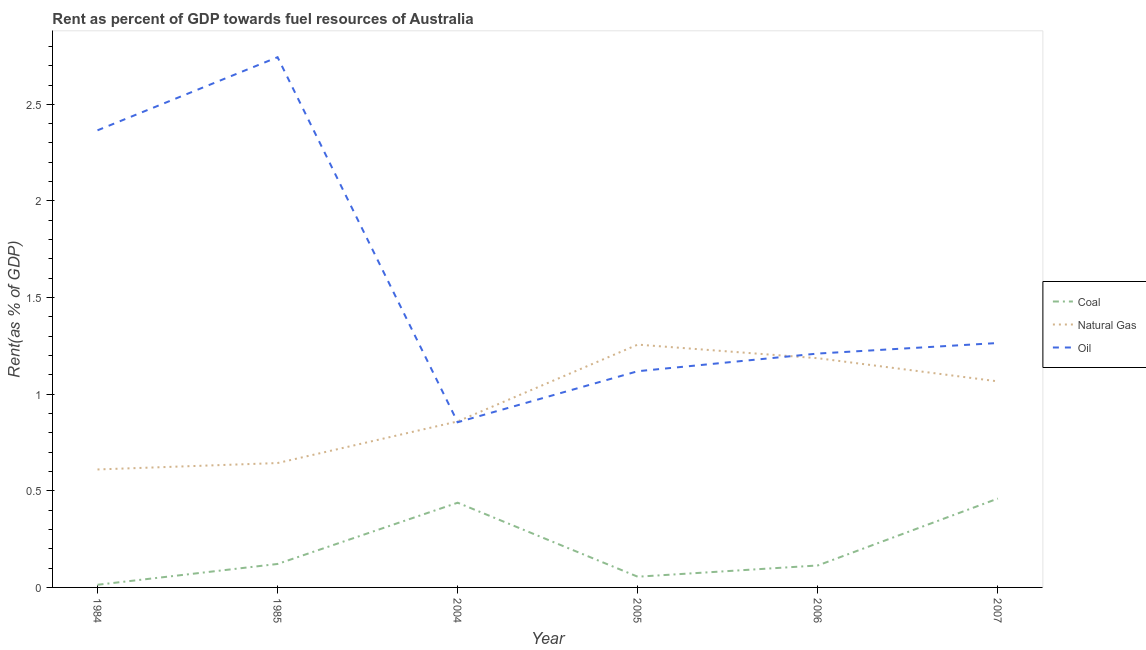Is the number of lines equal to the number of legend labels?
Provide a succinct answer. Yes. What is the rent towards coal in 2005?
Keep it short and to the point. 0.06. Across all years, what is the maximum rent towards natural gas?
Make the answer very short. 1.26. Across all years, what is the minimum rent towards natural gas?
Give a very brief answer. 0.61. In which year was the rent towards coal maximum?
Your answer should be compact. 2007. What is the total rent towards coal in the graph?
Make the answer very short. 1.2. What is the difference between the rent towards natural gas in 1984 and that in 2006?
Your response must be concise. -0.58. What is the difference between the rent towards oil in 1985 and the rent towards coal in 2005?
Make the answer very short. 2.69. What is the average rent towards oil per year?
Your answer should be very brief. 1.59. In the year 2007, what is the difference between the rent towards coal and rent towards natural gas?
Your response must be concise. -0.61. In how many years, is the rent towards natural gas greater than 0.8 %?
Give a very brief answer. 4. What is the ratio of the rent towards natural gas in 1984 to that in 2005?
Offer a terse response. 0.49. Is the rent towards coal in 1985 less than that in 2007?
Your response must be concise. Yes. What is the difference between the highest and the second highest rent towards coal?
Your answer should be very brief. 0.02. What is the difference between the highest and the lowest rent towards coal?
Provide a short and direct response. 0.45. Does the rent towards oil monotonically increase over the years?
Provide a short and direct response. No. Is the rent towards oil strictly greater than the rent towards coal over the years?
Give a very brief answer. Yes. What is the difference between two consecutive major ticks on the Y-axis?
Your answer should be compact. 0.5. Where does the legend appear in the graph?
Ensure brevity in your answer.  Center right. How many legend labels are there?
Your answer should be compact. 3. How are the legend labels stacked?
Your answer should be very brief. Vertical. What is the title of the graph?
Provide a succinct answer. Rent as percent of GDP towards fuel resources of Australia. What is the label or title of the X-axis?
Ensure brevity in your answer.  Year. What is the label or title of the Y-axis?
Make the answer very short. Rent(as % of GDP). What is the Rent(as % of GDP) of Coal in 1984?
Give a very brief answer. 0.01. What is the Rent(as % of GDP) in Natural Gas in 1984?
Your response must be concise. 0.61. What is the Rent(as % of GDP) in Oil in 1984?
Provide a succinct answer. 2.37. What is the Rent(as % of GDP) in Coal in 1985?
Your answer should be compact. 0.12. What is the Rent(as % of GDP) of Natural Gas in 1985?
Your response must be concise. 0.64. What is the Rent(as % of GDP) of Oil in 1985?
Provide a short and direct response. 2.74. What is the Rent(as % of GDP) in Coal in 2004?
Keep it short and to the point. 0.44. What is the Rent(as % of GDP) of Natural Gas in 2004?
Offer a very short reply. 0.86. What is the Rent(as % of GDP) in Oil in 2004?
Keep it short and to the point. 0.85. What is the Rent(as % of GDP) of Coal in 2005?
Ensure brevity in your answer.  0.06. What is the Rent(as % of GDP) in Natural Gas in 2005?
Your answer should be compact. 1.26. What is the Rent(as % of GDP) of Oil in 2005?
Give a very brief answer. 1.12. What is the Rent(as % of GDP) of Coal in 2006?
Keep it short and to the point. 0.11. What is the Rent(as % of GDP) in Natural Gas in 2006?
Provide a short and direct response. 1.19. What is the Rent(as % of GDP) of Oil in 2006?
Provide a short and direct response. 1.21. What is the Rent(as % of GDP) of Coal in 2007?
Provide a succinct answer. 0.46. What is the Rent(as % of GDP) in Natural Gas in 2007?
Ensure brevity in your answer.  1.07. What is the Rent(as % of GDP) in Oil in 2007?
Keep it short and to the point. 1.26. Across all years, what is the maximum Rent(as % of GDP) of Coal?
Offer a very short reply. 0.46. Across all years, what is the maximum Rent(as % of GDP) of Natural Gas?
Offer a terse response. 1.26. Across all years, what is the maximum Rent(as % of GDP) in Oil?
Offer a terse response. 2.74. Across all years, what is the minimum Rent(as % of GDP) of Coal?
Your answer should be very brief. 0.01. Across all years, what is the minimum Rent(as % of GDP) of Natural Gas?
Ensure brevity in your answer.  0.61. Across all years, what is the minimum Rent(as % of GDP) in Oil?
Offer a terse response. 0.85. What is the total Rent(as % of GDP) in Coal in the graph?
Offer a very short reply. 1.2. What is the total Rent(as % of GDP) of Natural Gas in the graph?
Offer a terse response. 5.62. What is the total Rent(as % of GDP) in Oil in the graph?
Your response must be concise. 9.56. What is the difference between the Rent(as % of GDP) of Coal in 1984 and that in 1985?
Offer a very short reply. -0.11. What is the difference between the Rent(as % of GDP) in Natural Gas in 1984 and that in 1985?
Offer a very short reply. -0.03. What is the difference between the Rent(as % of GDP) of Oil in 1984 and that in 1985?
Your response must be concise. -0.38. What is the difference between the Rent(as % of GDP) of Coal in 1984 and that in 2004?
Your answer should be very brief. -0.42. What is the difference between the Rent(as % of GDP) in Natural Gas in 1984 and that in 2004?
Provide a succinct answer. -0.25. What is the difference between the Rent(as % of GDP) of Oil in 1984 and that in 2004?
Offer a very short reply. 1.51. What is the difference between the Rent(as % of GDP) of Coal in 1984 and that in 2005?
Your response must be concise. -0.04. What is the difference between the Rent(as % of GDP) in Natural Gas in 1984 and that in 2005?
Provide a succinct answer. -0.65. What is the difference between the Rent(as % of GDP) of Oil in 1984 and that in 2005?
Provide a succinct answer. 1.25. What is the difference between the Rent(as % of GDP) of Coal in 1984 and that in 2006?
Ensure brevity in your answer.  -0.1. What is the difference between the Rent(as % of GDP) in Natural Gas in 1984 and that in 2006?
Ensure brevity in your answer.  -0.58. What is the difference between the Rent(as % of GDP) of Oil in 1984 and that in 2006?
Make the answer very short. 1.16. What is the difference between the Rent(as % of GDP) in Coal in 1984 and that in 2007?
Your response must be concise. -0.45. What is the difference between the Rent(as % of GDP) of Natural Gas in 1984 and that in 2007?
Provide a succinct answer. -0.46. What is the difference between the Rent(as % of GDP) in Oil in 1984 and that in 2007?
Provide a short and direct response. 1.1. What is the difference between the Rent(as % of GDP) in Coal in 1985 and that in 2004?
Offer a very short reply. -0.32. What is the difference between the Rent(as % of GDP) of Natural Gas in 1985 and that in 2004?
Give a very brief answer. -0.22. What is the difference between the Rent(as % of GDP) in Oil in 1985 and that in 2004?
Provide a succinct answer. 1.89. What is the difference between the Rent(as % of GDP) in Coal in 1985 and that in 2005?
Offer a terse response. 0.07. What is the difference between the Rent(as % of GDP) of Natural Gas in 1985 and that in 2005?
Provide a short and direct response. -0.61. What is the difference between the Rent(as % of GDP) in Oil in 1985 and that in 2005?
Offer a terse response. 1.62. What is the difference between the Rent(as % of GDP) in Coal in 1985 and that in 2006?
Offer a very short reply. 0.01. What is the difference between the Rent(as % of GDP) of Natural Gas in 1985 and that in 2006?
Make the answer very short. -0.54. What is the difference between the Rent(as % of GDP) of Oil in 1985 and that in 2006?
Ensure brevity in your answer.  1.53. What is the difference between the Rent(as % of GDP) of Coal in 1985 and that in 2007?
Give a very brief answer. -0.34. What is the difference between the Rent(as % of GDP) in Natural Gas in 1985 and that in 2007?
Your response must be concise. -0.42. What is the difference between the Rent(as % of GDP) in Oil in 1985 and that in 2007?
Offer a terse response. 1.48. What is the difference between the Rent(as % of GDP) in Coal in 2004 and that in 2005?
Offer a very short reply. 0.38. What is the difference between the Rent(as % of GDP) of Natural Gas in 2004 and that in 2005?
Offer a very short reply. -0.4. What is the difference between the Rent(as % of GDP) of Oil in 2004 and that in 2005?
Make the answer very short. -0.26. What is the difference between the Rent(as % of GDP) in Coal in 2004 and that in 2006?
Ensure brevity in your answer.  0.32. What is the difference between the Rent(as % of GDP) of Natural Gas in 2004 and that in 2006?
Ensure brevity in your answer.  -0.33. What is the difference between the Rent(as % of GDP) in Oil in 2004 and that in 2006?
Provide a succinct answer. -0.36. What is the difference between the Rent(as % of GDP) of Coal in 2004 and that in 2007?
Provide a succinct answer. -0.02. What is the difference between the Rent(as % of GDP) of Natural Gas in 2004 and that in 2007?
Make the answer very short. -0.21. What is the difference between the Rent(as % of GDP) of Oil in 2004 and that in 2007?
Your answer should be very brief. -0.41. What is the difference between the Rent(as % of GDP) of Coal in 2005 and that in 2006?
Give a very brief answer. -0.06. What is the difference between the Rent(as % of GDP) in Natural Gas in 2005 and that in 2006?
Ensure brevity in your answer.  0.07. What is the difference between the Rent(as % of GDP) of Oil in 2005 and that in 2006?
Your response must be concise. -0.09. What is the difference between the Rent(as % of GDP) in Coal in 2005 and that in 2007?
Your response must be concise. -0.4. What is the difference between the Rent(as % of GDP) in Natural Gas in 2005 and that in 2007?
Offer a terse response. 0.19. What is the difference between the Rent(as % of GDP) of Oil in 2005 and that in 2007?
Keep it short and to the point. -0.15. What is the difference between the Rent(as % of GDP) of Coal in 2006 and that in 2007?
Keep it short and to the point. -0.35. What is the difference between the Rent(as % of GDP) in Natural Gas in 2006 and that in 2007?
Provide a succinct answer. 0.12. What is the difference between the Rent(as % of GDP) of Oil in 2006 and that in 2007?
Your response must be concise. -0.05. What is the difference between the Rent(as % of GDP) of Coal in 1984 and the Rent(as % of GDP) of Natural Gas in 1985?
Provide a succinct answer. -0.63. What is the difference between the Rent(as % of GDP) of Coal in 1984 and the Rent(as % of GDP) of Oil in 1985?
Ensure brevity in your answer.  -2.73. What is the difference between the Rent(as % of GDP) in Natural Gas in 1984 and the Rent(as % of GDP) in Oil in 1985?
Provide a succinct answer. -2.13. What is the difference between the Rent(as % of GDP) of Coal in 1984 and the Rent(as % of GDP) of Natural Gas in 2004?
Make the answer very short. -0.85. What is the difference between the Rent(as % of GDP) in Coal in 1984 and the Rent(as % of GDP) in Oil in 2004?
Offer a very short reply. -0.84. What is the difference between the Rent(as % of GDP) in Natural Gas in 1984 and the Rent(as % of GDP) in Oil in 2004?
Give a very brief answer. -0.24. What is the difference between the Rent(as % of GDP) of Coal in 1984 and the Rent(as % of GDP) of Natural Gas in 2005?
Offer a terse response. -1.24. What is the difference between the Rent(as % of GDP) of Coal in 1984 and the Rent(as % of GDP) of Oil in 2005?
Keep it short and to the point. -1.11. What is the difference between the Rent(as % of GDP) of Natural Gas in 1984 and the Rent(as % of GDP) of Oil in 2005?
Give a very brief answer. -0.51. What is the difference between the Rent(as % of GDP) in Coal in 1984 and the Rent(as % of GDP) in Natural Gas in 2006?
Give a very brief answer. -1.17. What is the difference between the Rent(as % of GDP) in Coal in 1984 and the Rent(as % of GDP) in Oil in 2006?
Provide a short and direct response. -1.2. What is the difference between the Rent(as % of GDP) in Natural Gas in 1984 and the Rent(as % of GDP) in Oil in 2006?
Provide a short and direct response. -0.6. What is the difference between the Rent(as % of GDP) in Coal in 1984 and the Rent(as % of GDP) in Natural Gas in 2007?
Your answer should be compact. -1.05. What is the difference between the Rent(as % of GDP) of Coal in 1984 and the Rent(as % of GDP) of Oil in 2007?
Your response must be concise. -1.25. What is the difference between the Rent(as % of GDP) in Natural Gas in 1984 and the Rent(as % of GDP) in Oil in 2007?
Make the answer very short. -0.65. What is the difference between the Rent(as % of GDP) of Coal in 1985 and the Rent(as % of GDP) of Natural Gas in 2004?
Ensure brevity in your answer.  -0.74. What is the difference between the Rent(as % of GDP) in Coal in 1985 and the Rent(as % of GDP) in Oil in 2004?
Provide a short and direct response. -0.73. What is the difference between the Rent(as % of GDP) in Natural Gas in 1985 and the Rent(as % of GDP) in Oil in 2004?
Provide a short and direct response. -0.21. What is the difference between the Rent(as % of GDP) in Coal in 1985 and the Rent(as % of GDP) in Natural Gas in 2005?
Provide a succinct answer. -1.14. What is the difference between the Rent(as % of GDP) in Coal in 1985 and the Rent(as % of GDP) in Oil in 2005?
Your answer should be compact. -1. What is the difference between the Rent(as % of GDP) of Natural Gas in 1985 and the Rent(as % of GDP) of Oil in 2005?
Your answer should be compact. -0.48. What is the difference between the Rent(as % of GDP) of Coal in 1985 and the Rent(as % of GDP) of Natural Gas in 2006?
Give a very brief answer. -1.06. What is the difference between the Rent(as % of GDP) of Coal in 1985 and the Rent(as % of GDP) of Oil in 2006?
Keep it short and to the point. -1.09. What is the difference between the Rent(as % of GDP) of Natural Gas in 1985 and the Rent(as % of GDP) of Oil in 2006?
Your answer should be very brief. -0.57. What is the difference between the Rent(as % of GDP) of Coal in 1985 and the Rent(as % of GDP) of Natural Gas in 2007?
Provide a short and direct response. -0.94. What is the difference between the Rent(as % of GDP) in Coal in 1985 and the Rent(as % of GDP) in Oil in 2007?
Make the answer very short. -1.14. What is the difference between the Rent(as % of GDP) of Natural Gas in 1985 and the Rent(as % of GDP) of Oil in 2007?
Provide a short and direct response. -0.62. What is the difference between the Rent(as % of GDP) in Coal in 2004 and the Rent(as % of GDP) in Natural Gas in 2005?
Offer a terse response. -0.82. What is the difference between the Rent(as % of GDP) of Coal in 2004 and the Rent(as % of GDP) of Oil in 2005?
Provide a short and direct response. -0.68. What is the difference between the Rent(as % of GDP) of Natural Gas in 2004 and the Rent(as % of GDP) of Oil in 2005?
Your answer should be very brief. -0.26. What is the difference between the Rent(as % of GDP) in Coal in 2004 and the Rent(as % of GDP) in Natural Gas in 2006?
Give a very brief answer. -0.75. What is the difference between the Rent(as % of GDP) of Coal in 2004 and the Rent(as % of GDP) of Oil in 2006?
Ensure brevity in your answer.  -0.77. What is the difference between the Rent(as % of GDP) of Natural Gas in 2004 and the Rent(as % of GDP) of Oil in 2006?
Offer a terse response. -0.35. What is the difference between the Rent(as % of GDP) of Coal in 2004 and the Rent(as % of GDP) of Natural Gas in 2007?
Make the answer very short. -0.63. What is the difference between the Rent(as % of GDP) of Coal in 2004 and the Rent(as % of GDP) of Oil in 2007?
Provide a succinct answer. -0.83. What is the difference between the Rent(as % of GDP) in Natural Gas in 2004 and the Rent(as % of GDP) in Oil in 2007?
Ensure brevity in your answer.  -0.41. What is the difference between the Rent(as % of GDP) of Coal in 2005 and the Rent(as % of GDP) of Natural Gas in 2006?
Give a very brief answer. -1.13. What is the difference between the Rent(as % of GDP) in Coal in 2005 and the Rent(as % of GDP) in Oil in 2006?
Provide a succinct answer. -1.15. What is the difference between the Rent(as % of GDP) of Natural Gas in 2005 and the Rent(as % of GDP) of Oil in 2006?
Make the answer very short. 0.05. What is the difference between the Rent(as % of GDP) of Coal in 2005 and the Rent(as % of GDP) of Natural Gas in 2007?
Your answer should be very brief. -1.01. What is the difference between the Rent(as % of GDP) of Coal in 2005 and the Rent(as % of GDP) of Oil in 2007?
Your answer should be very brief. -1.21. What is the difference between the Rent(as % of GDP) of Natural Gas in 2005 and the Rent(as % of GDP) of Oil in 2007?
Provide a succinct answer. -0.01. What is the difference between the Rent(as % of GDP) in Coal in 2006 and the Rent(as % of GDP) in Natural Gas in 2007?
Your answer should be compact. -0.95. What is the difference between the Rent(as % of GDP) in Coal in 2006 and the Rent(as % of GDP) in Oil in 2007?
Keep it short and to the point. -1.15. What is the difference between the Rent(as % of GDP) of Natural Gas in 2006 and the Rent(as % of GDP) of Oil in 2007?
Provide a short and direct response. -0.08. What is the average Rent(as % of GDP) in Coal per year?
Your response must be concise. 0.2. What is the average Rent(as % of GDP) of Natural Gas per year?
Provide a succinct answer. 0.94. What is the average Rent(as % of GDP) in Oil per year?
Your response must be concise. 1.59. In the year 1984, what is the difference between the Rent(as % of GDP) in Coal and Rent(as % of GDP) in Natural Gas?
Your answer should be compact. -0.6. In the year 1984, what is the difference between the Rent(as % of GDP) in Coal and Rent(as % of GDP) in Oil?
Your answer should be very brief. -2.35. In the year 1984, what is the difference between the Rent(as % of GDP) of Natural Gas and Rent(as % of GDP) of Oil?
Provide a short and direct response. -1.75. In the year 1985, what is the difference between the Rent(as % of GDP) in Coal and Rent(as % of GDP) in Natural Gas?
Your answer should be very brief. -0.52. In the year 1985, what is the difference between the Rent(as % of GDP) in Coal and Rent(as % of GDP) in Oil?
Your answer should be very brief. -2.62. In the year 1985, what is the difference between the Rent(as % of GDP) of Natural Gas and Rent(as % of GDP) of Oil?
Give a very brief answer. -2.1. In the year 2004, what is the difference between the Rent(as % of GDP) in Coal and Rent(as % of GDP) in Natural Gas?
Your response must be concise. -0.42. In the year 2004, what is the difference between the Rent(as % of GDP) in Coal and Rent(as % of GDP) in Oil?
Your response must be concise. -0.42. In the year 2004, what is the difference between the Rent(as % of GDP) of Natural Gas and Rent(as % of GDP) of Oil?
Your answer should be compact. 0. In the year 2005, what is the difference between the Rent(as % of GDP) of Coal and Rent(as % of GDP) of Natural Gas?
Offer a very short reply. -1.2. In the year 2005, what is the difference between the Rent(as % of GDP) in Coal and Rent(as % of GDP) in Oil?
Your answer should be compact. -1.06. In the year 2005, what is the difference between the Rent(as % of GDP) in Natural Gas and Rent(as % of GDP) in Oil?
Provide a short and direct response. 0.14. In the year 2006, what is the difference between the Rent(as % of GDP) of Coal and Rent(as % of GDP) of Natural Gas?
Your answer should be compact. -1.07. In the year 2006, what is the difference between the Rent(as % of GDP) of Coal and Rent(as % of GDP) of Oil?
Your response must be concise. -1.1. In the year 2006, what is the difference between the Rent(as % of GDP) of Natural Gas and Rent(as % of GDP) of Oil?
Make the answer very short. -0.02. In the year 2007, what is the difference between the Rent(as % of GDP) in Coal and Rent(as % of GDP) in Natural Gas?
Offer a very short reply. -0.61. In the year 2007, what is the difference between the Rent(as % of GDP) of Coal and Rent(as % of GDP) of Oil?
Your response must be concise. -0.81. In the year 2007, what is the difference between the Rent(as % of GDP) in Natural Gas and Rent(as % of GDP) in Oil?
Provide a succinct answer. -0.2. What is the ratio of the Rent(as % of GDP) in Coal in 1984 to that in 1985?
Keep it short and to the point. 0.11. What is the ratio of the Rent(as % of GDP) in Natural Gas in 1984 to that in 1985?
Give a very brief answer. 0.95. What is the ratio of the Rent(as % of GDP) of Oil in 1984 to that in 1985?
Make the answer very short. 0.86. What is the ratio of the Rent(as % of GDP) of Coal in 1984 to that in 2004?
Provide a short and direct response. 0.03. What is the ratio of the Rent(as % of GDP) of Natural Gas in 1984 to that in 2004?
Offer a terse response. 0.71. What is the ratio of the Rent(as % of GDP) in Oil in 1984 to that in 2004?
Keep it short and to the point. 2.77. What is the ratio of the Rent(as % of GDP) of Coal in 1984 to that in 2005?
Make the answer very short. 0.25. What is the ratio of the Rent(as % of GDP) in Natural Gas in 1984 to that in 2005?
Ensure brevity in your answer.  0.49. What is the ratio of the Rent(as % of GDP) of Oil in 1984 to that in 2005?
Keep it short and to the point. 2.11. What is the ratio of the Rent(as % of GDP) of Coal in 1984 to that in 2006?
Provide a short and direct response. 0.12. What is the ratio of the Rent(as % of GDP) in Natural Gas in 1984 to that in 2006?
Give a very brief answer. 0.51. What is the ratio of the Rent(as % of GDP) in Oil in 1984 to that in 2006?
Provide a succinct answer. 1.95. What is the ratio of the Rent(as % of GDP) in Coal in 1984 to that in 2007?
Make the answer very short. 0.03. What is the ratio of the Rent(as % of GDP) of Natural Gas in 1984 to that in 2007?
Offer a very short reply. 0.57. What is the ratio of the Rent(as % of GDP) in Oil in 1984 to that in 2007?
Your response must be concise. 1.87. What is the ratio of the Rent(as % of GDP) in Coal in 1985 to that in 2004?
Make the answer very short. 0.28. What is the ratio of the Rent(as % of GDP) in Natural Gas in 1985 to that in 2004?
Ensure brevity in your answer.  0.75. What is the ratio of the Rent(as % of GDP) in Oil in 1985 to that in 2004?
Keep it short and to the point. 3.21. What is the ratio of the Rent(as % of GDP) of Coal in 1985 to that in 2005?
Your answer should be very brief. 2.19. What is the ratio of the Rent(as % of GDP) in Natural Gas in 1985 to that in 2005?
Your answer should be very brief. 0.51. What is the ratio of the Rent(as % of GDP) of Oil in 1985 to that in 2005?
Provide a succinct answer. 2.45. What is the ratio of the Rent(as % of GDP) in Coal in 1985 to that in 2006?
Provide a short and direct response. 1.07. What is the ratio of the Rent(as % of GDP) of Natural Gas in 1985 to that in 2006?
Offer a terse response. 0.54. What is the ratio of the Rent(as % of GDP) of Oil in 1985 to that in 2006?
Ensure brevity in your answer.  2.27. What is the ratio of the Rent(as % of GDP) in Coal in 1985 to that in 2007?
Your response must be concise. 0.26. What is the ratio of the Rent(as % of GDP) of Natural Gas in 1985 to that in 2007?
Keep it short and to the point. 0.6. What is the ratio of the Rent(as % of GDP) of Oil in 1985 to that in 2007?
Keep it short and to the point. 2.17. What is the ratio of the Rent(as % of GDP) of Coal in 2004 to that in 2005?
Provide a succinct answer. 7.91. What is the ratio of the Rent(as % of GDP) in Natural Gas in 2004 to that in 2005?
Provide a succinct answer. 0.68. What is the ratio of the Rent(as % of GDP) in Oil in 2004 to that in 2005?
Provide a succinct answer. 0.76. What is the ratio of the Rent(as % of GDP) in Coal in 2004 to that in 2006?
Offer a terse response. 3.86. What is the ratio of the Rent(as % of GDP) in Natural Gas in 2004 to that in 2006?
Give a very brief answer. 0.72. What is the ratio of the Rent(as % of GDP) in Oil in 2004 to that in 2006?
Provide a short and direct response. 0.71. What is the ratio of the Rent(as % of GDP) in Coal in 2004 to that in 2007?
Provide a succinct answer. 0.95. What is the ratio of the Rent(as % of GDP) of Natural Gas in 2004 to that in 2007?
Offer a very short reply. 0.81. What is the ratio of the Rent(as % of GDP) of Oil in 2004 to that in 2007?
Your answer should be very brief. 0.68. What is the ratio of the Rent(as % of GDP) of Coal in 2005 to that in 2006?
Your response must be concise. 0.49. What is the ratio of the Rent(as % of GDP) in Natural Gas in 2005 to that in 2006?
Offer a very short reply. 1.06. What is the ratio of the Rent(as % of GDP) of Oil in 2005 to that in 2006?
Keep it short and to the point. 0.92. What is the ratio of the Rent(as % of GDP) of Coal in 2005 to that in 2007?
Your answer should be very brief. 0.12. What is the ratio of the Rent(as % of GDP) of Natural Gas in 2005 to that in 2007?
Provide a short and direct response. 1.18. What is the ratio of the Rent(as % of GDP) in Oil in 2005 to that in 2007?
Make the answer very short. 0.88. What is the ratio of the Rent(as % of GDP) of Coal in 2006 to that in 2007?
Keep it short and to the point. 0.25. What is the ratio of the Rent(as % of GDP) of Natural Gas in 2006 to that in 2007?
Offer a very short reply. 1.11. What is the ratio of the Rent(as % of GDP) in Oil in 2006 to that in 2007?
Your response must be concise. 0.96. What is the difference between the highest and the second highest Rent(as % of GDP) of Coal?
Offer a very short reply. 0.02. What is the difference between the highest and the second highest Rent(as % of GDP) of Natural Gas?
Give a very brief answer. 0.07. What is the difference between the highest and the second highest Rent(as % of GDP) of Oil?
Your answer should be compact. 0.38. What is the difference between the highest and the lowest Rent(as % of GDP) in Coal?
Offer a terse response. 0.45. What is the difference between the highest and the lowest Rent(as % of GDP) of Natural Gas?
Your answer should be very brief. 0.65. What is the difference between the highest and the lowest Rent(as % of GDP) in Oil?
Provide a short and direct response. 1.89. 